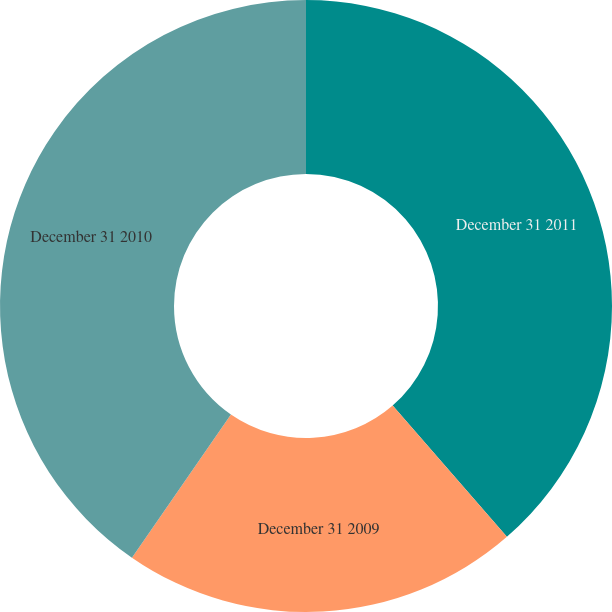Convert chart to OTSL. <chart><loc_0><loc_0><loc_500><loc_500><pie_chart><fcel>December 31 2011<fcel>December 31 2009<fcel>December 31 2010<nl><fcel>38.6%<fcel>21.03%<fcel>40.37%<nl></chart> 